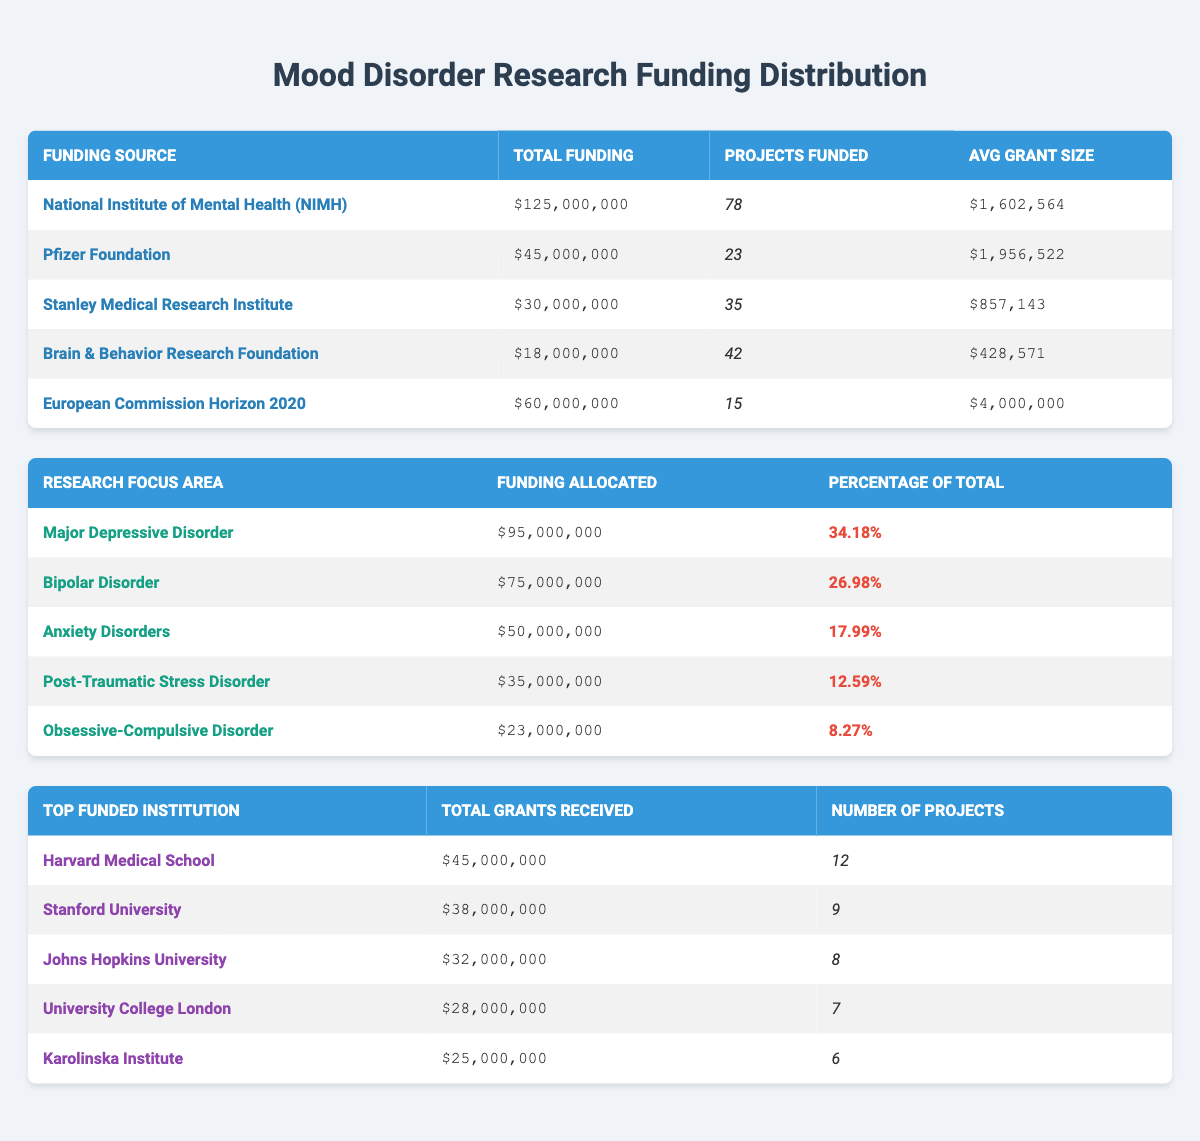What is the total funding from the National Institute of Mental Health? The table shows that the total funding from the National Institute of Mental Health is listed as $125,000,000.
Answer: $125,000,000 How many projects were funded by the Pfizer Foundation? According to the table, the Pfizer Foundation funded a total of 23 projects.
Answer: 23 Which funding source has the highest average grant size? The average grant sizes for each source are given as follows: NIMH - $1,602,564, Pfizer Foundation - $1,956,522, Stanley Medical Research Institute - $857,143, Brain & Behavior Research Foundation - $428,571, and European Commission Horizon 2020 - $4,000,000. The highest average grant size is from the European Commission Horizon 2020 at $4,000,000.
Answer: $4,000,000 What percentage of the total funding is allocated to Major Depressive Disorder? The table indicates that funding allocated to Major Depressive Disorder is $95,000,000. To find the percentage, we look at the total funding, which is $277,000,000 (the sum of all funding sources), and calculate (95,000,000 / 277,000,000) * 100, which equals 34.18%.
Answer: 34.18% Is the total funding for Anxiety Disorders greater than that for Post-Traumatic Stress Disorder? The table shows that funding for Anxiety Disorders is $50,000,000, and for Post-Traumatic Stress Disorder, it is $35,000,000. Since 50,000,000 is greater than 35,000,000, the answer is yes.
Answer: Yes What is the sum of the total grants received by the top three funded institutions? The total grants received by the top three institutions are: Harvard Medical School - $45,000,000, Stanford University - $38,000,000, and Johns Hopkins University - $32,000,000. Adding these amounts together gives $45,000,000 + $38,000,000 + $32,000,000 = $115,000,000.
Answer: $115,000,000 Does the Brain & Behavior Research Foundation fund more projects than the Stanley Medical Research Institute? The table shows that the Brain & Behavior Research Foundation funded 42 projects while the Stanley Medical Research Institute funded 35. Since 42 is greater than 35, the answer is yes.
Answer: Yes How much funding is allocated to Obsessive-Compulsive Disorder compared to Anxiety Disorders? The funding for Obsessive-Compulsive Disorder is $23,000,000 and for Anxiety Disorders is $50,000,000. Since $23,000,000 is less than $50,000,000, the difference is $50,000,000 - $23,000,000 = $27,000,000, meaning Anxiety Disorders receives $27,000,000 more than Obsessive-Compulsive Disorder.
Answer: $27,000,000 What is the average number of projects funded by the top five institutions? The total number of projects funded by the top five institutions is 12 (Harvard) + 9 (Stanford) + 8 (Johns Hopkins) + 7 (UCL) + 6 (Karolinska) = 42. There are five institutions, so the average is 42 / 5 = 8.4.
Answer: 8.4 